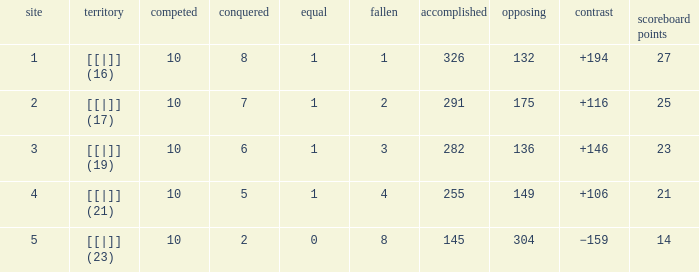 How many games had a deficit of 175?  1.0. 